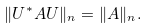<formula> <loc_0><loc_0><loc_500><loc_500>\| U ^ { * } A U \| _ { n } = \| A \| _ { n } .</formula> 